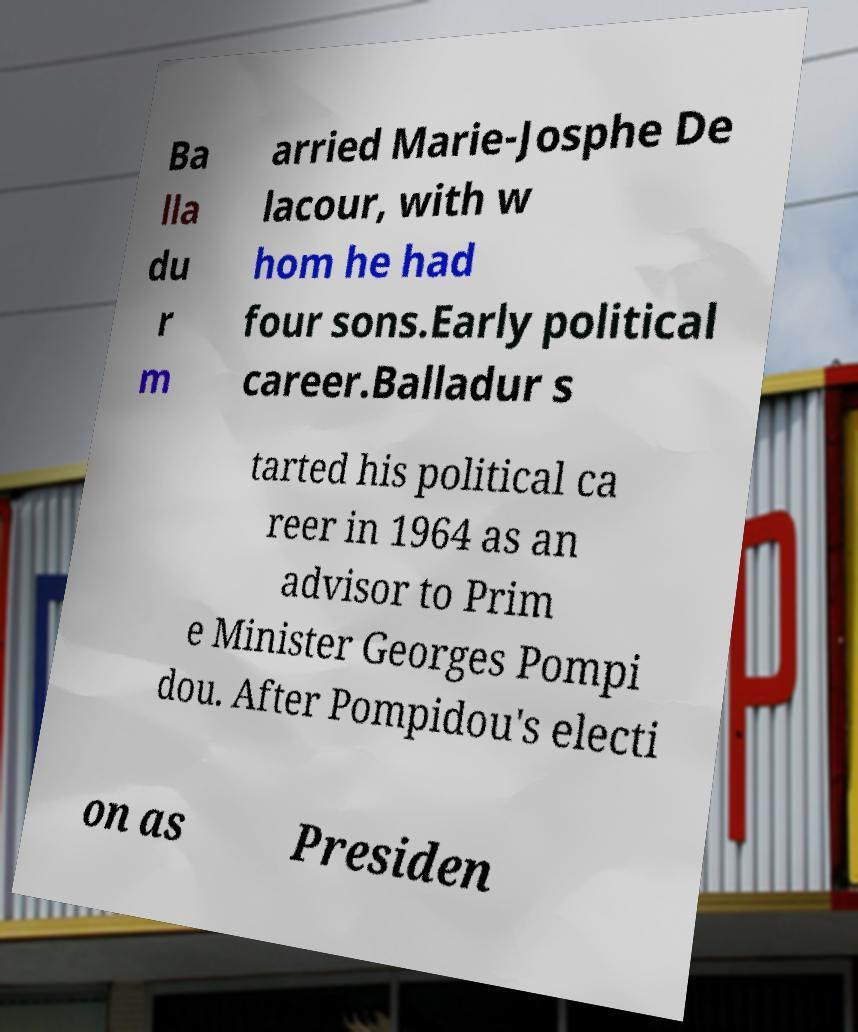For documentation purposes, I need the text within this image transcribed. Could you provide that? Ba lla du r m arried Marie-Josphe De lacour, with w hom he had four sons.Early political career.Balladur s tarted his political ca reer in 1964 as an advisor to Prim e Minister Georges Pompi dou. After Pompidou's electi on as Presiden 